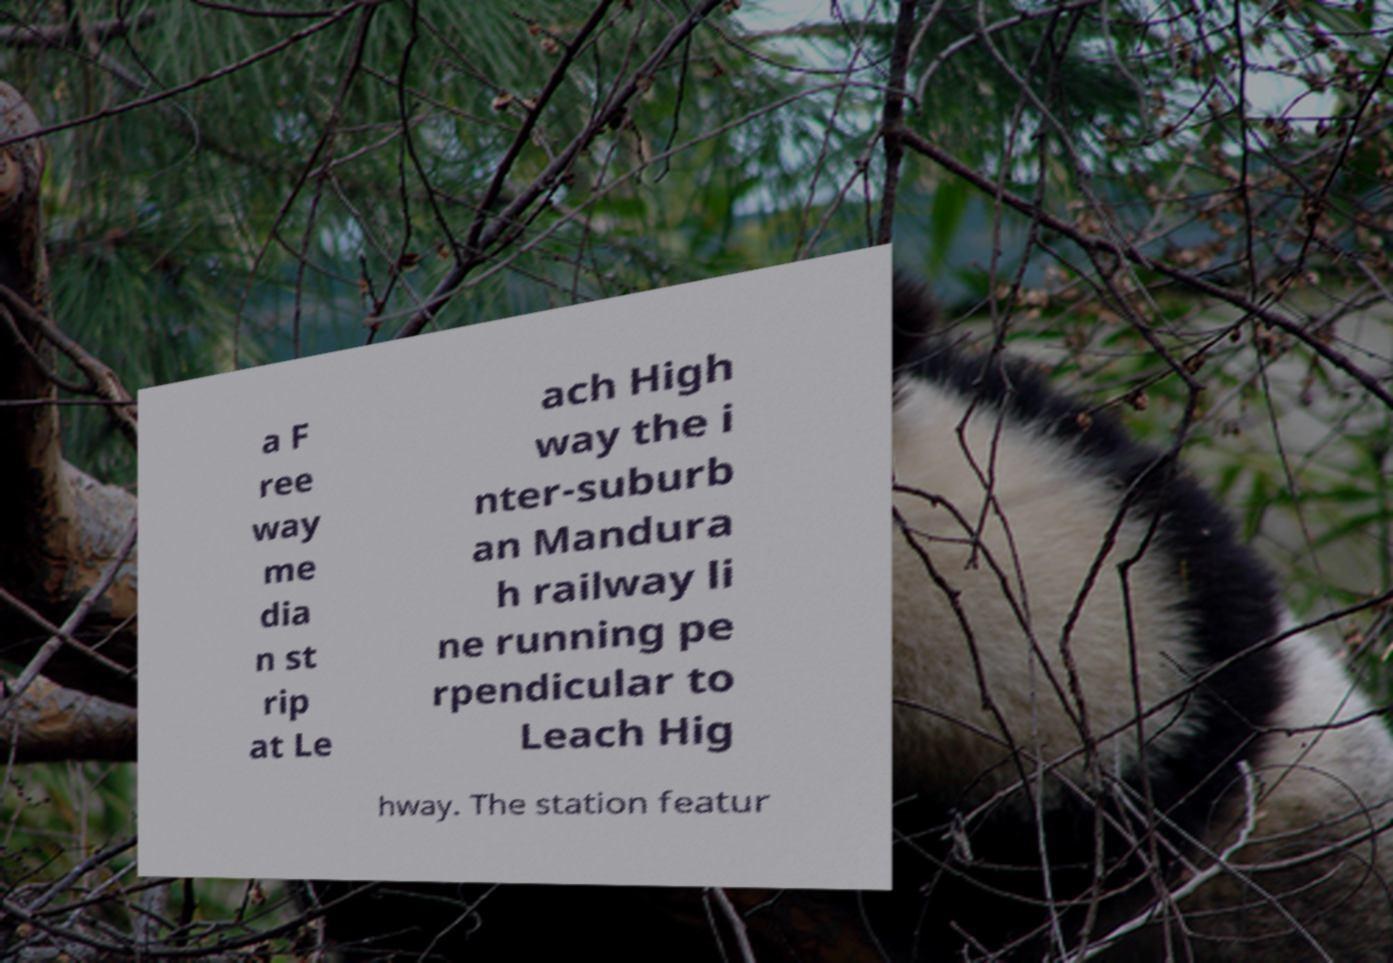Could you assist in decoding the text presented in this image and type it out clearly? a F ree way me dia n st rip at Le ach High way the i nter-suburb an Mandura h railway li ne running pe rpendicular to Leach Hig hway. The station featur 